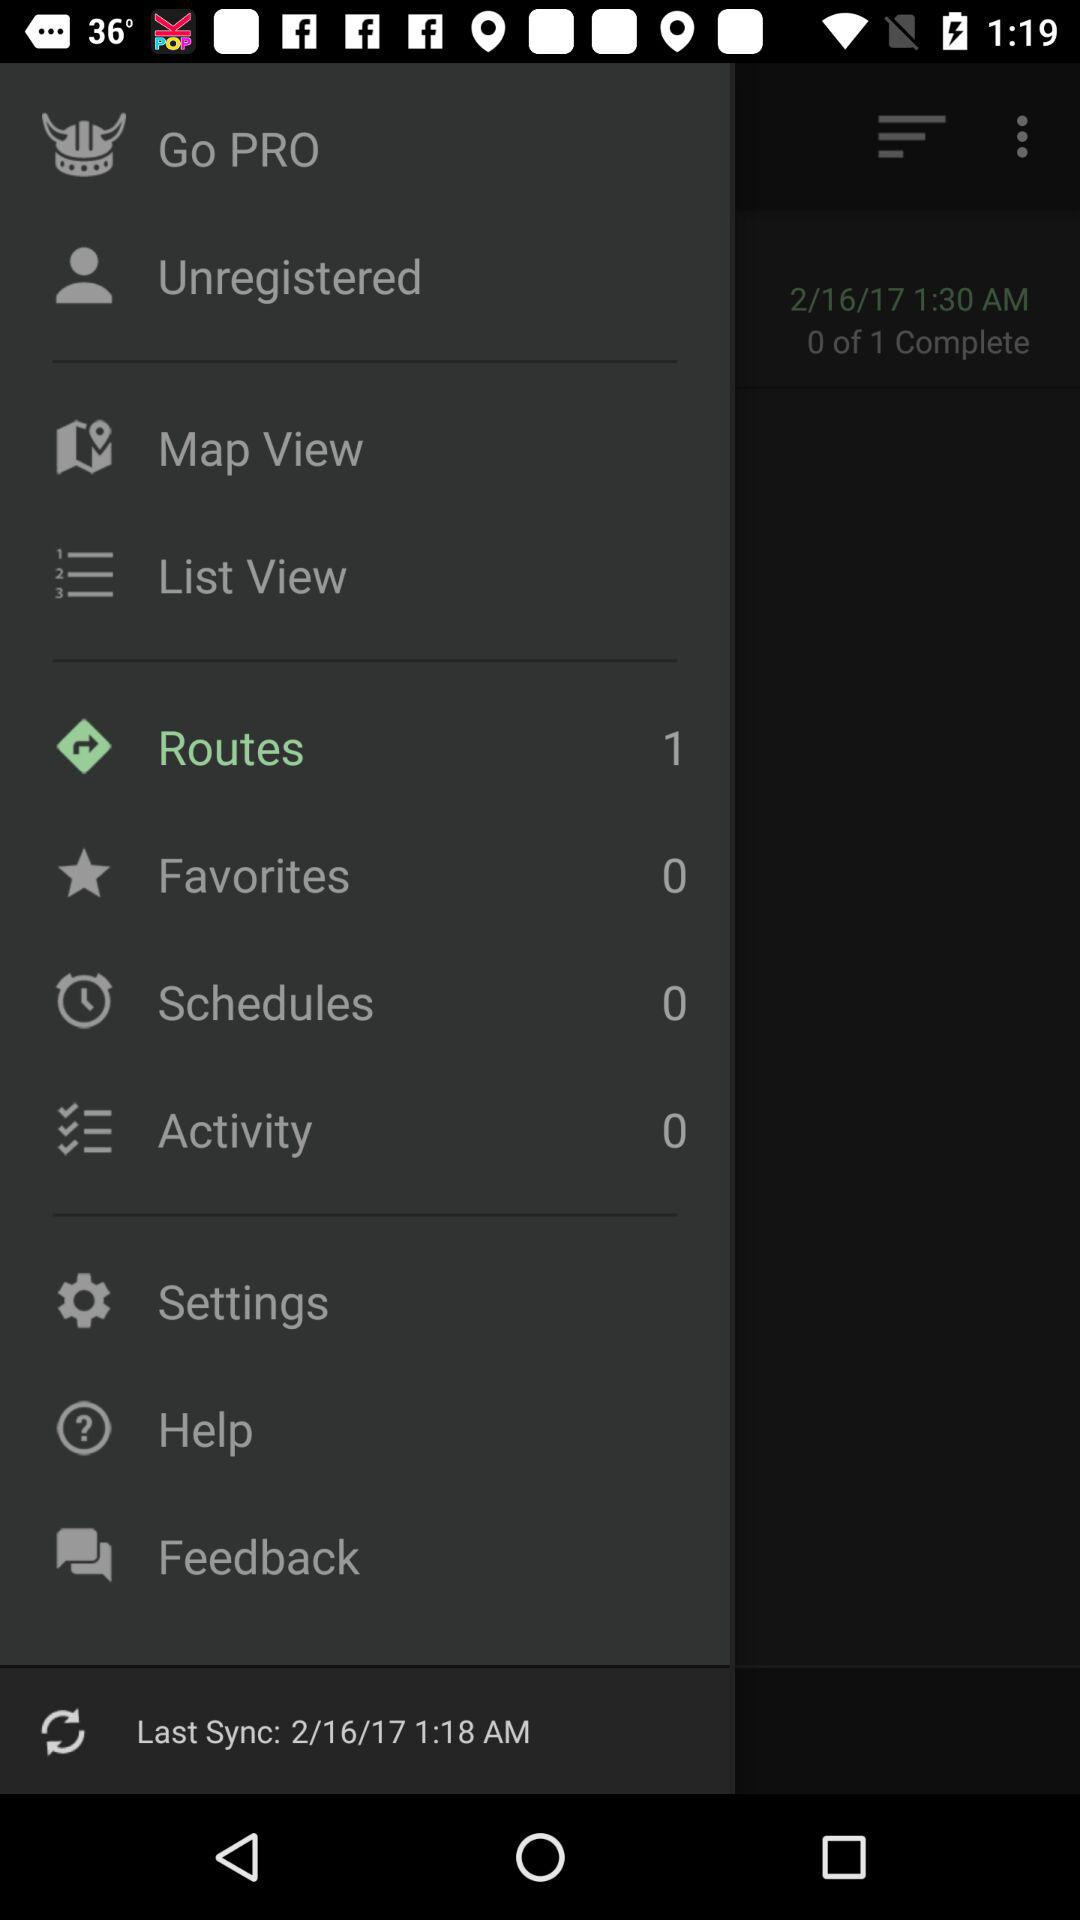How many favorites are there? There are 0 favorites. 